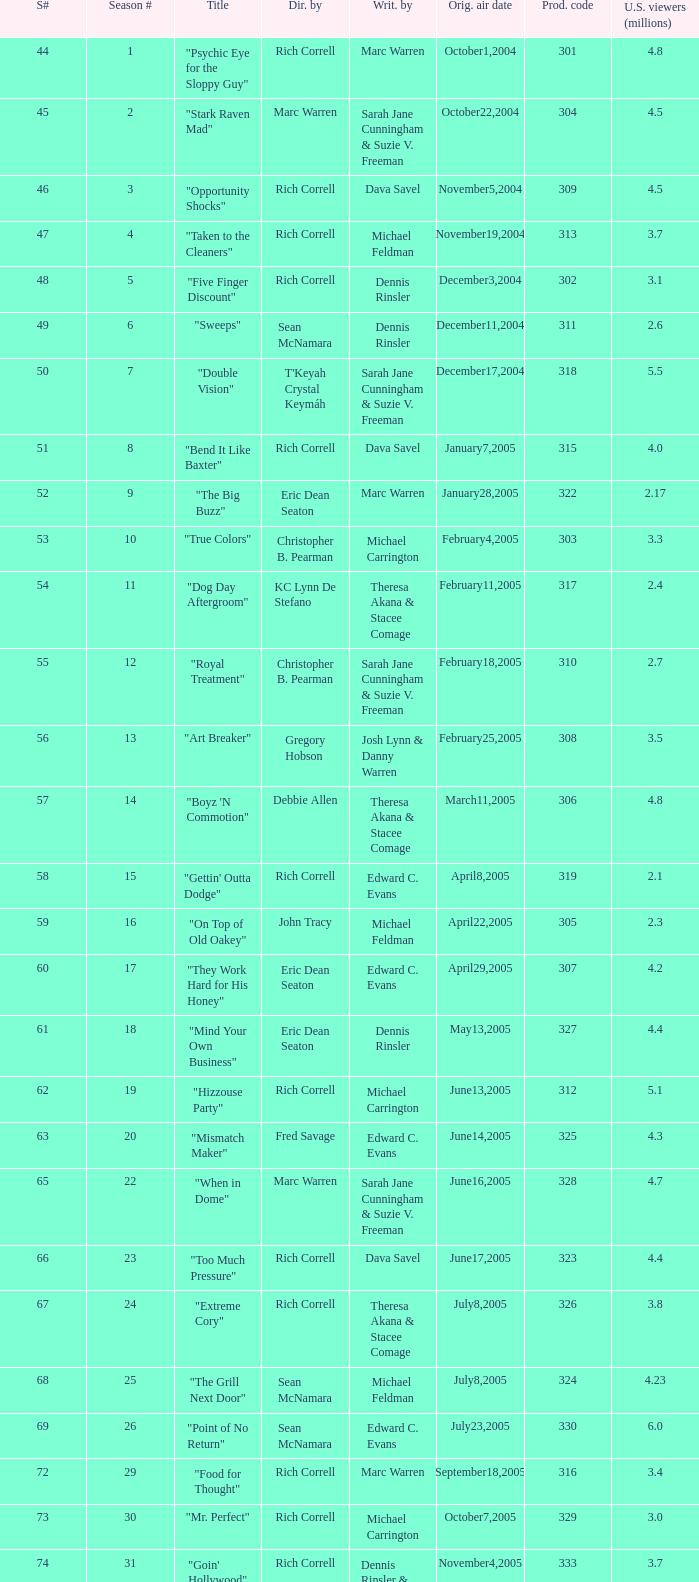What is the title of the episode directed by Rich Correll and written by Dennis Rinsler? "Five Finger Discount". 